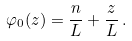Convert formula to latex. <formula><loc_0><loc_0><loc_500><loc_500>\varphi _ { 0 } ( z ) = \frac { n } { L } + \frac { z } { L } \, .</formula> 